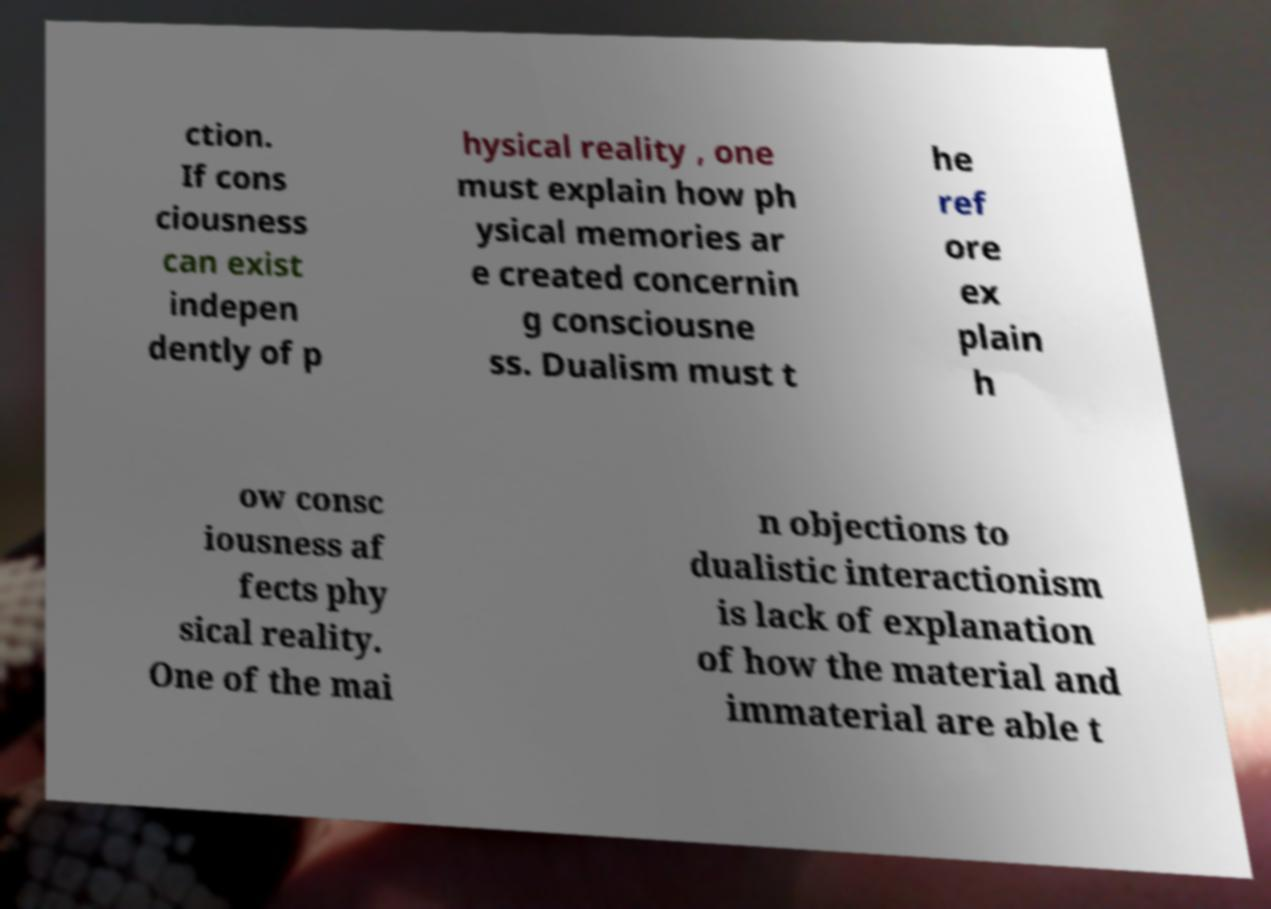There's text embedded in this image that I need extracted. Can you transcribe it verbatim? ction. If cons ciousness can exist indepen dently of p hysical reality , one must explain how ph ysical memories ar e created concernin g consciousne ss. Dualism must t he ref ore ex plain h ow consc iousness af fects phy sical reality. One of the mai n objections to dualistic interactionism is lack of explanation of how the material and immaterial are able t 